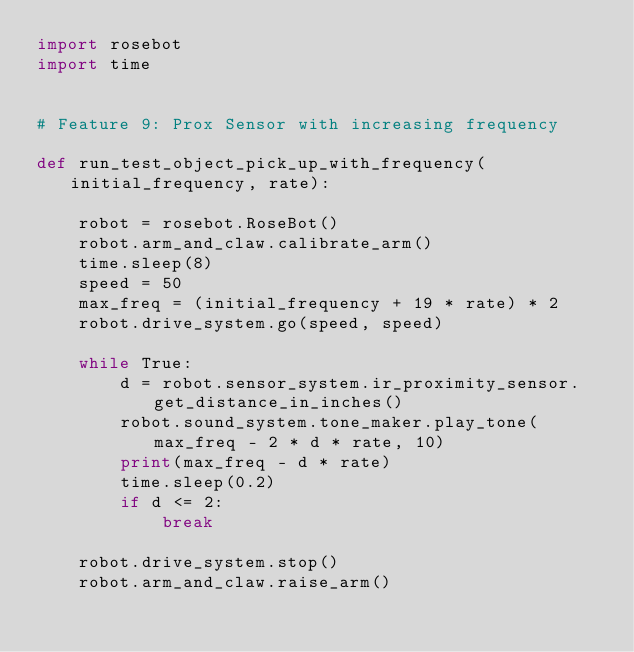Convert code to text. <code><loc_0><loc_0><loc_500><loc_500><_Python_>import rosebot
import time


# Feature 9: Prox Sensor with increasing frequency

def run_test_object_pick_up_with_frequency(initial_frequency, rate):

    robot = rosebot.RoseBot()
    robot.arm_and_claw.calibrate_arm()
    time.sleep(8)
    speed = 50
    max_freq = (initial_frequency + 19 * rate) * 2
    robot.drive_system.go(speed, speed)

    while True:
        d = robot.sensor_system.ir_proximity_sensor.get_distance_in_inches()
        robot.sound_system.tone_maker.play_tone(max_freq - 2 * d * rate, 10)
        print(max_freq - d * rate)
        time.sleep(0.2)
        if d <= 2:
            break

    robot.drive_system.stop()
    robot.arm_and_claw.raise_arm()</code> 